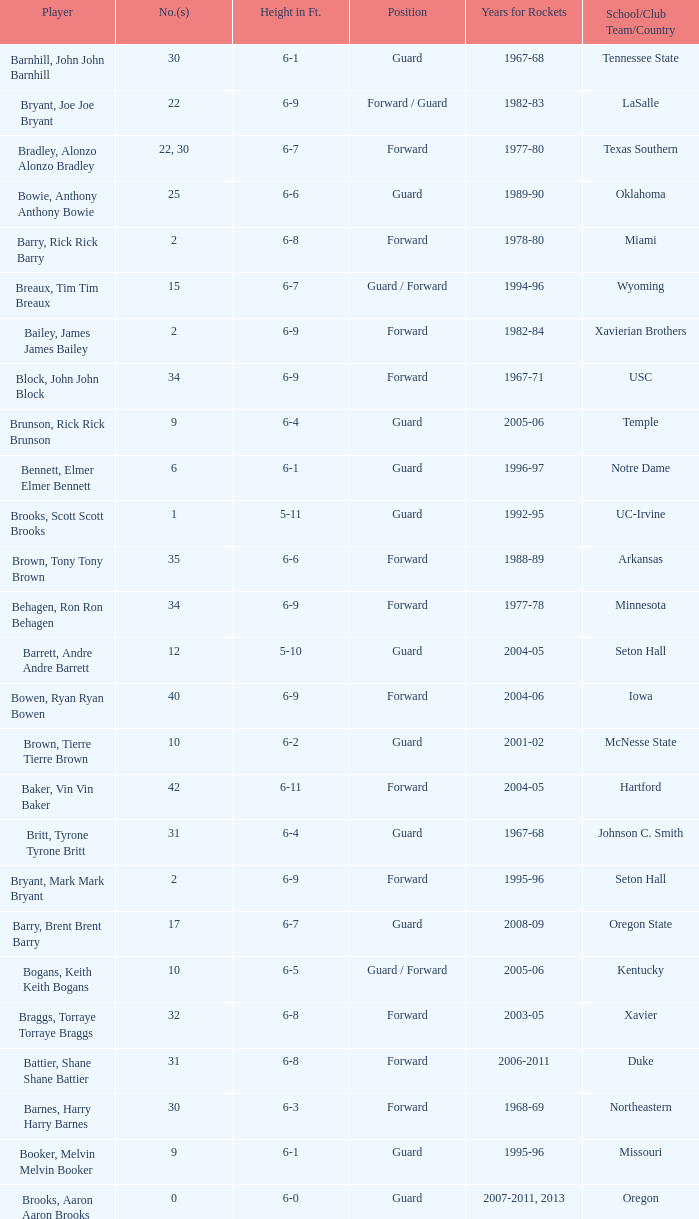What position is number 35 whose height is 6-6? Forward. 